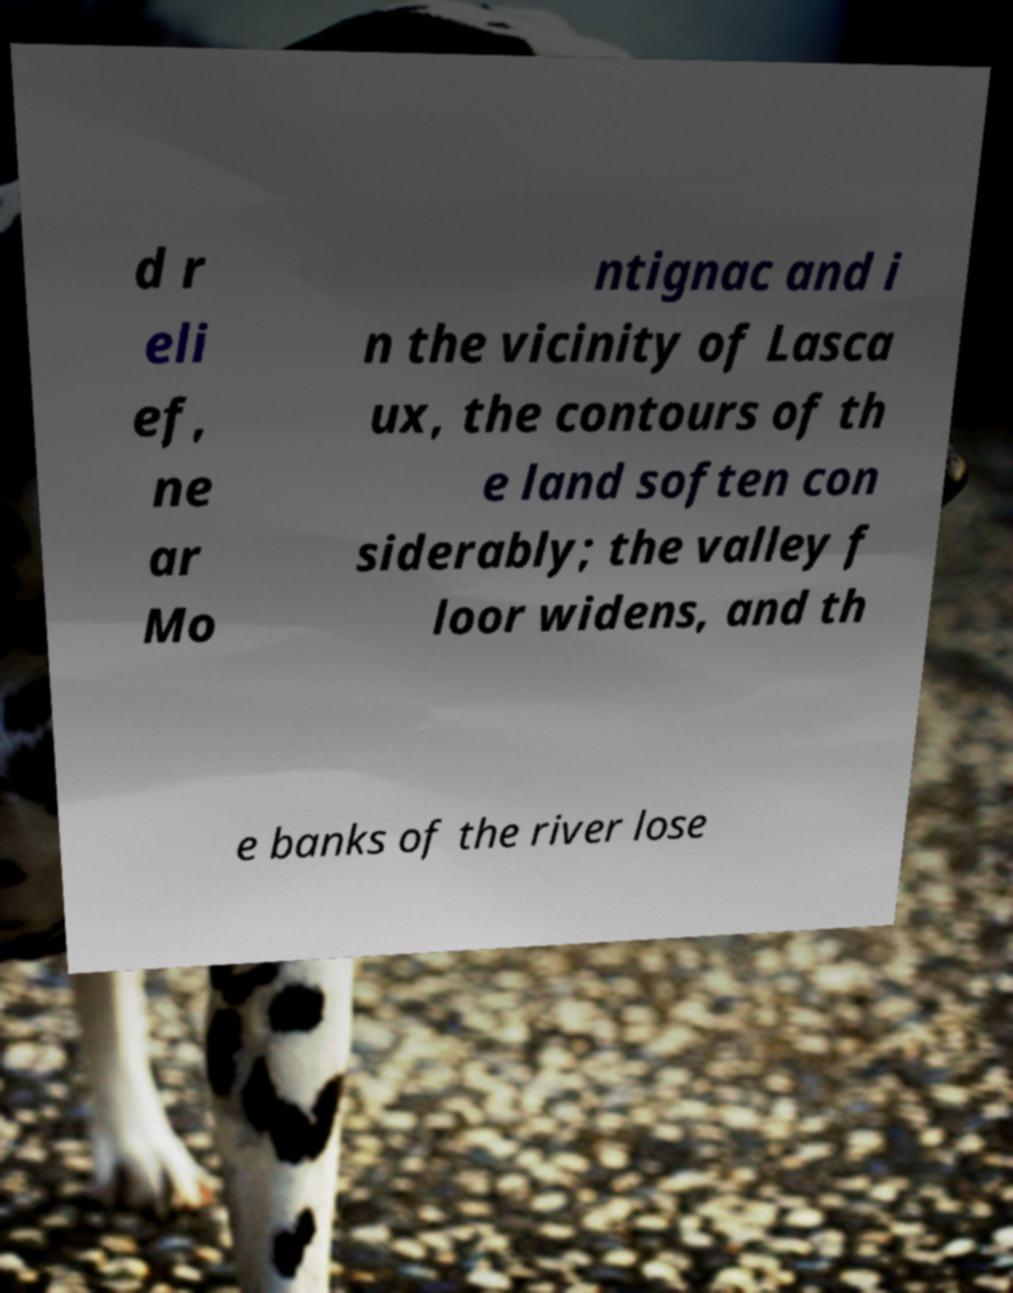I need the written content from this picture converted into text. Can you do that? d r eli ef, ne ar Mo ntignac and i n the vicinity of Lasca ux, the contours of th e land soften con siderably; the valley f loor widens, and th e banks of the river lose 